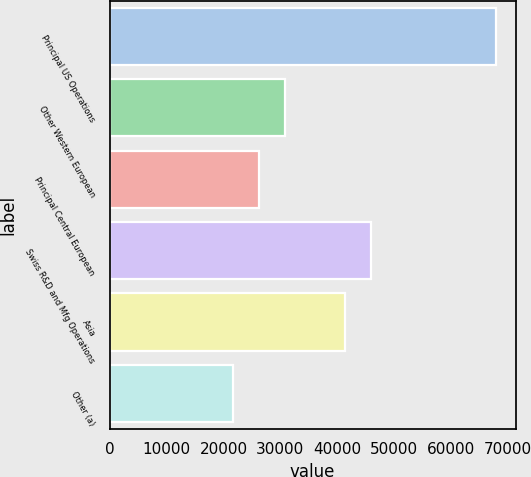Convert chart. <chart><loc_0><loc_0><loc_500><loc_500><bar_chart><fcel>Principal US Operations<fcel>Other Western European<fcel>Principal Central European<fcel>Swiss R&D and Mfg Operations<fcel>Asia<fcel>Other (a)<nl><fcel>67901<fcel>30861.8<fcel>26231.9<fcel>45905.9<fcel>41276<fcel>21602<nl></chart> 